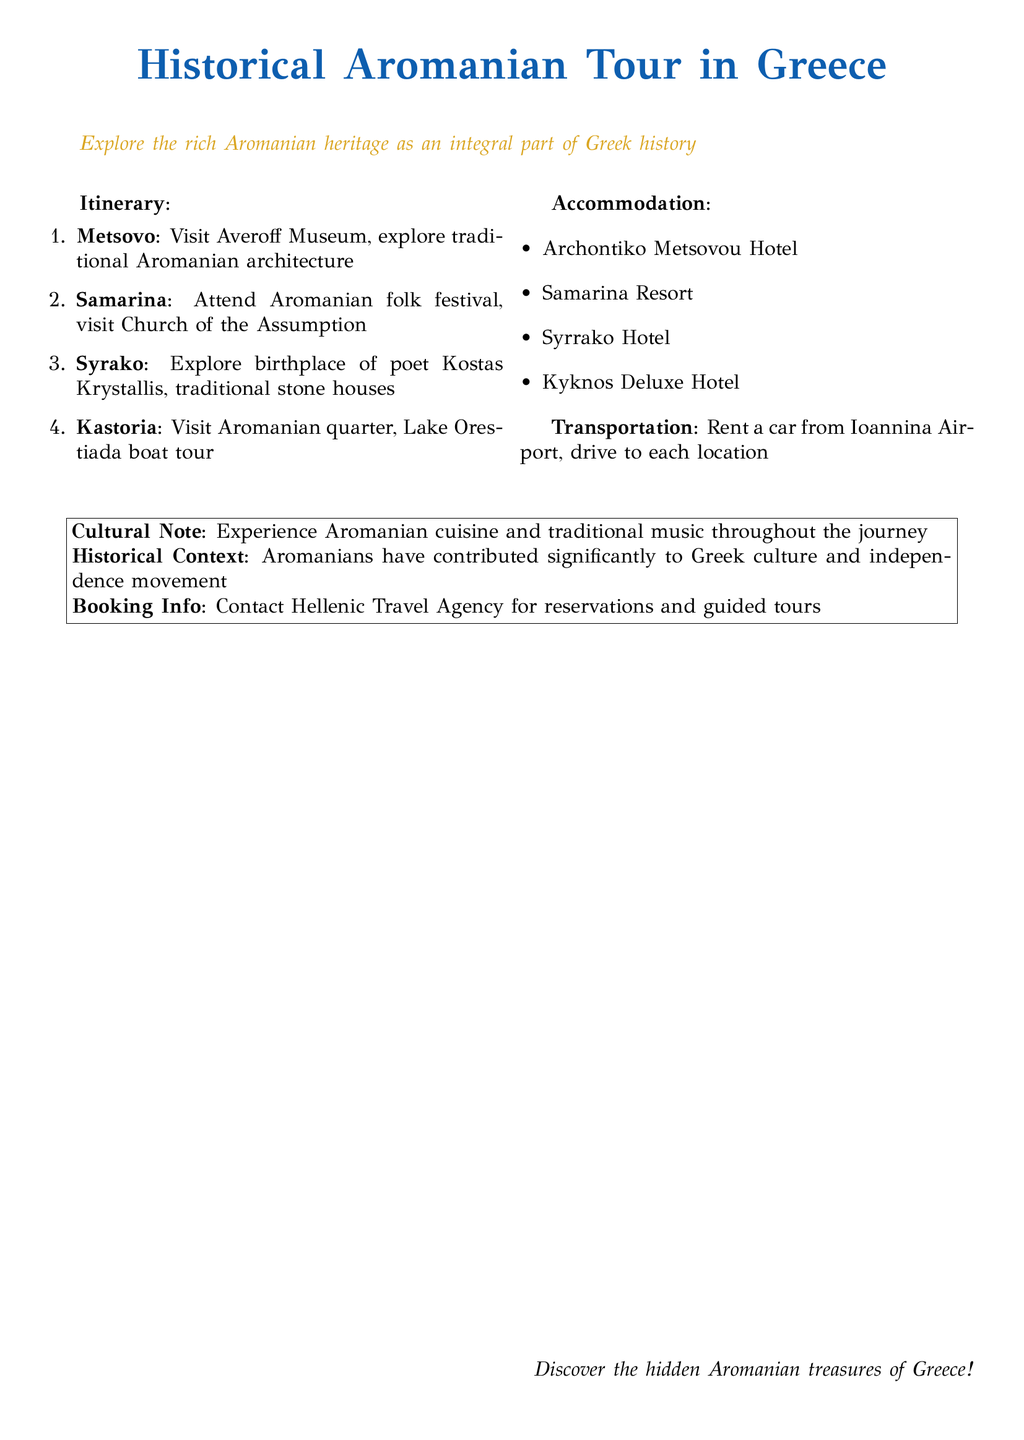What is the first location in the itinerary? The first location listed in the itinerary is Metsovo.
Answer: Metsovo How many hotels are listed for accommodation? The document provides a list of four hotels for accommodation.
Answer: 4 What type of festival can you attend in Samarina? The itinerary mentions an Aromanian folk festival taking place in Samarina.
Answer: Aromanian folk festival Which lake is featured in the Kastoria portion of the itinerary? The itinerary states that there is a boat tour on Lake Orestiada in Kastoria.
Answer: Lake Orestiada What transportation method is recommended for the tour? The document suggests renting a car from Ioannina Airport for transportation during the tour.
Answer: Rent a car What type of cuisine is highlighted in the cultural note? The cultural note emphasizes the experience of Aromanian cuisine during the journey.
Answer: Aromanian cuisine Which agency is suggested for bookings? The document recommends contacting Hellenic Travel Agency for reservations and guided tours.
Answer: Hellenic Travel Agency What is the name of the museum to visit in Metsovo? The Averoff Museum is the recommended museum to visit in Metsovo.
Answer: Averoff Museum 